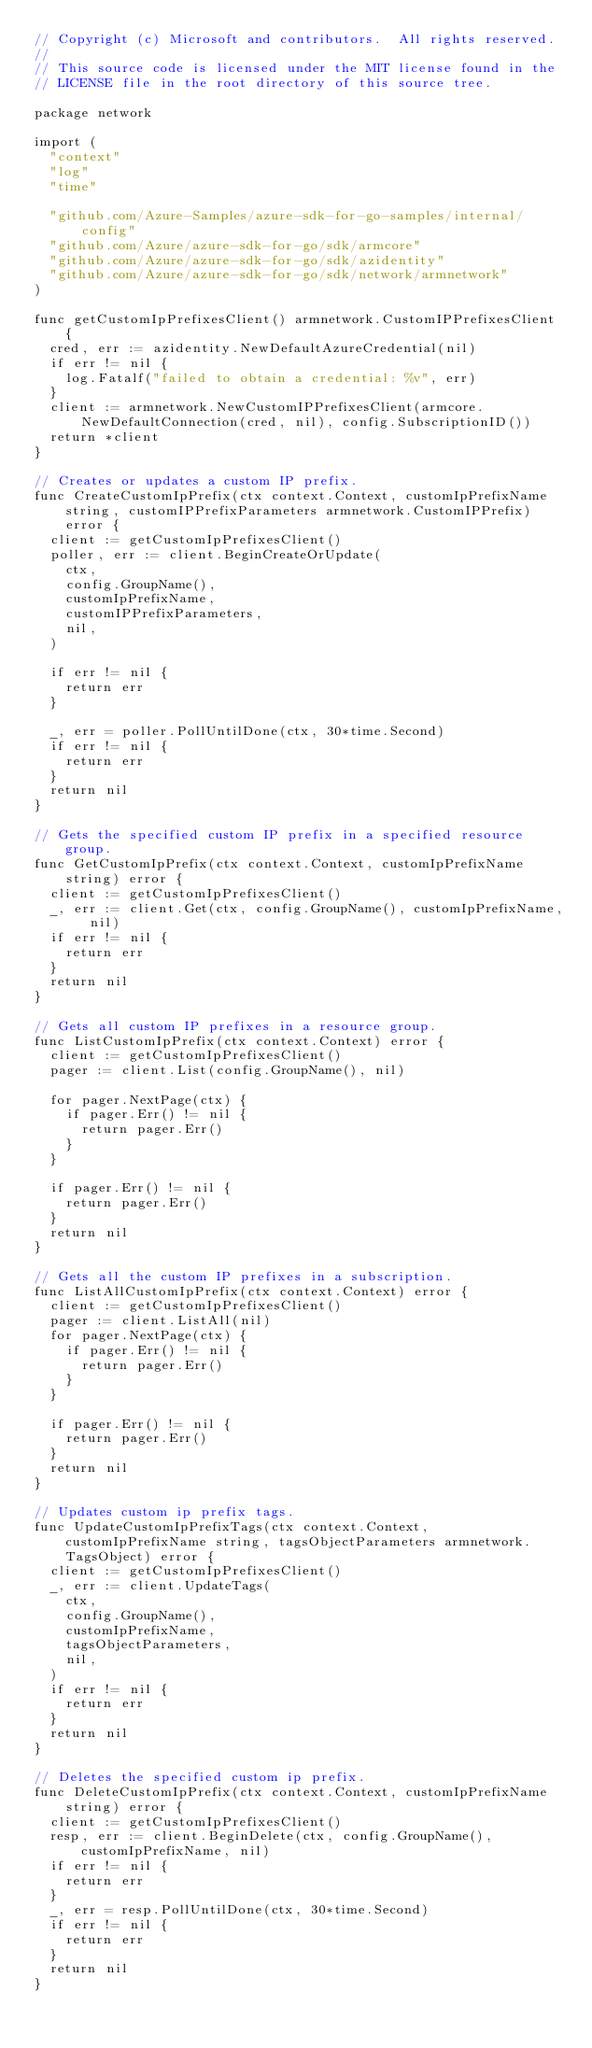Convert code to text. <code><loc_0><loc_0><loc_500><loc_500><_Go_>// Copyright (c) Microsoft and contributors.  All rights reserved.
//
// This source code is licensed under the MIT license found in the
// LICENSE file in the root directory of this source tree.

package network

import (
	"context"
	"log"
	"time"

	"github.com/Azure-Samples/azure-sdk-for-go-samples/internal/config"
	"github.com/Azure/azure-sdk-for-go/sdk/armcore"
	"github.com/Azure/azure-sdk-for-go/sdk/azidentity"
	"github.com/Azure/azure-sdk-for-go/sdk/network/armnetwork"
)

func getCustomIpPrefixesClient() armnetwork.CustomIPPrefixesClient {
	cred, err := azidentity.NewDefaultAzureCredential(nil)
	if err != nil {
		log.Fatalf("failed to obtain a credential: %v", err)
	}
	client := armnetwork.NewCustomIPPrefixesClient(armcore.NewDefaultConnection(cred, nil), config.SubscriptionID())
	return *client
}

// Creates or updates a custom IP prefix.
func CreateCustomIpPrefix(ctx context.Context, customIpPrefixName string, customIPPrefixParameters armnetwork.CustomIPPrefix) error {
	client := getCustomIpPrefixesClient()
	poller, err := client.BeginCreateOrUpdate(
		ctx,
		config.GroupName(),
		customIpPrefixName,
		customIPPrefixParameters,
		nil,
	)

	if err != nil {
		return err
	}

	_, err = poller.PollUntilDone(ctx, 30*time.Second)
	if err != nil {
		return err
	}
	return nil
}

// Gets the specified custom IP prefix in a specified resource group.
func GetCustomIpPrefix(ctx context.Context, customIpPrefixName string) error {
	client := getCustomIpPrefixesClient()
	_, err := client.Get(ctx, config.GroupName(), customIpPrefixName, nil)
	if err != nil {
		return err
	}
	return nil
}

// Gets all custom IP prefixes in a resource group.
func ListCustomIpPrefix(ctx context.Context) error {
	client := getCustomIpPrefixesClient()
	pager := client.List(config.GroupName(), nil)

	for pager.NextPage(ctx) {
		if pager.Err() != nil {
			return pager.Err()
		}
	}

	if pager.Err() != nil {
		return pager.Err()
	}
	return nil
}

// Gets all the custom IP prefixes in a subscription.
func ListAllCustomIpPrefix(ctx context.Context) error {
	client := getCustomIpPrefixesClient()
	pager := client.ListAll(nil)
	for pager.NextPage(ctx) {
		if pager.Err() != nil {
			return pager.Err()
		}
	}

	if pager.Err() != nil {
		return pager.Err()
	}
	return nil
}

// Updates custom ip prefix tags.
func UpdateCustomIpPrefixTags(ctx context.Context, customIpPrefixName string, tagsObjectParameters armnetwork.TagsObject) error {
	client := getCustomIpPrefixesClient()
	_, err := client.UpdateTags(
		ctx,
		config.GroupName(),
		customIpPrefixName,
		tagsObjectParameters,
		nil,
	)
	if err != nil {
		return err
	}
	return nil
}

// Deletes the specified custom ip prefix.
func DeleteCustomIpPrefix(ctx context.Context, customIpPrefixName string) error {
	client := getCustomIpPrefixesClient()
	resp, err := client.BeginDelete(ctx, config.GroupName(), customIpPrefixName, nil)
	if err != nil {
		return err
	}
	_, err = resp.PollUntilDone(ctx, 30*time.Second)
	if err != nil {
		return err
	}
	return nil
}
</code> 